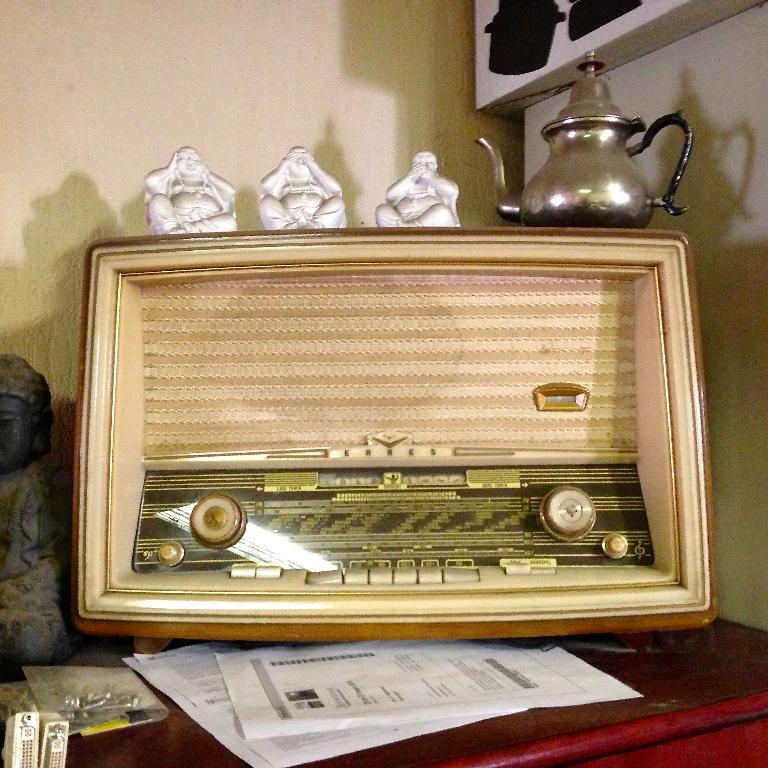What is the main object in the image? There is a device in the image. What other objects can be seen in the image? There are statues, papers, a kettle, and objects on a table in the image. What is visible in the background of the image? There is a wall and an object in the background of the image. What type of creature is writing on the papers in the image? There is no creature present in the image, and no one is writing on the papers. How does the acoustics of the room affect the sound of the device in the image? The provided facts do not mention anything about the acoustics of the room, so it is impossible to determine how they might affect the sound of the device. 